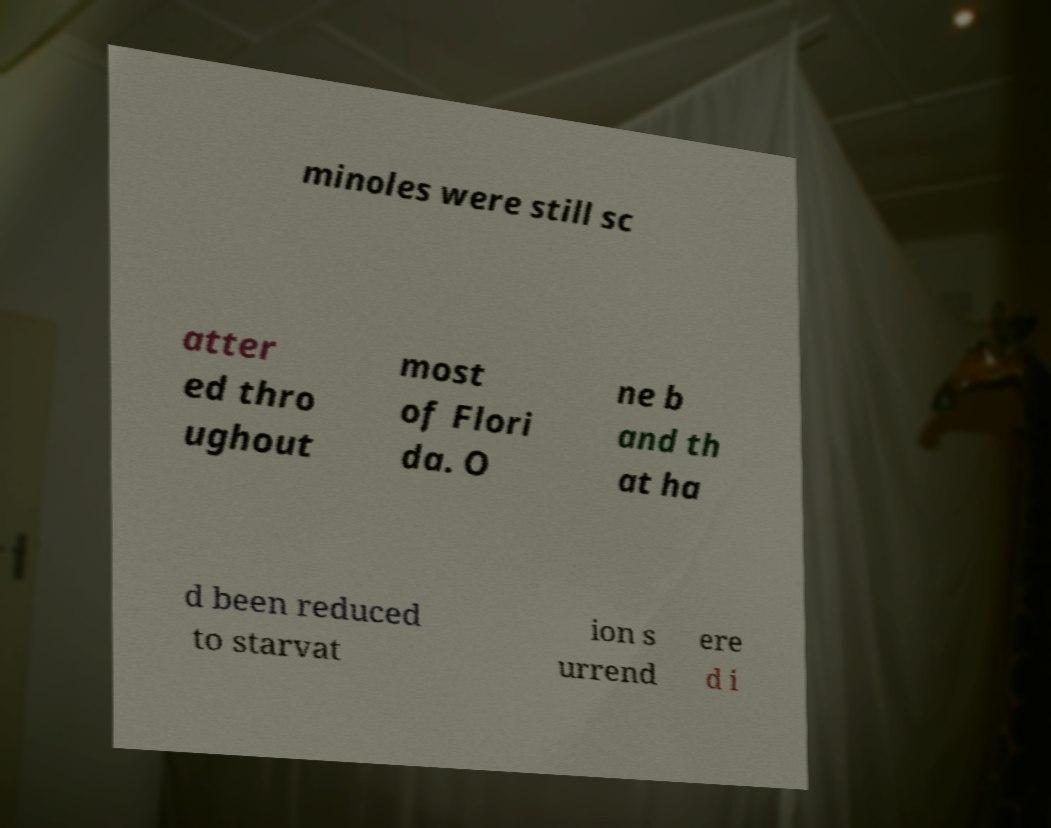For documentation purposes, I need the text within this image transcribed. Could you provide that? minoles were still sc atter ed thro ughout most of Flori da. O ne b and th at ha d been reduced to starvat ion s urrend ere d i 